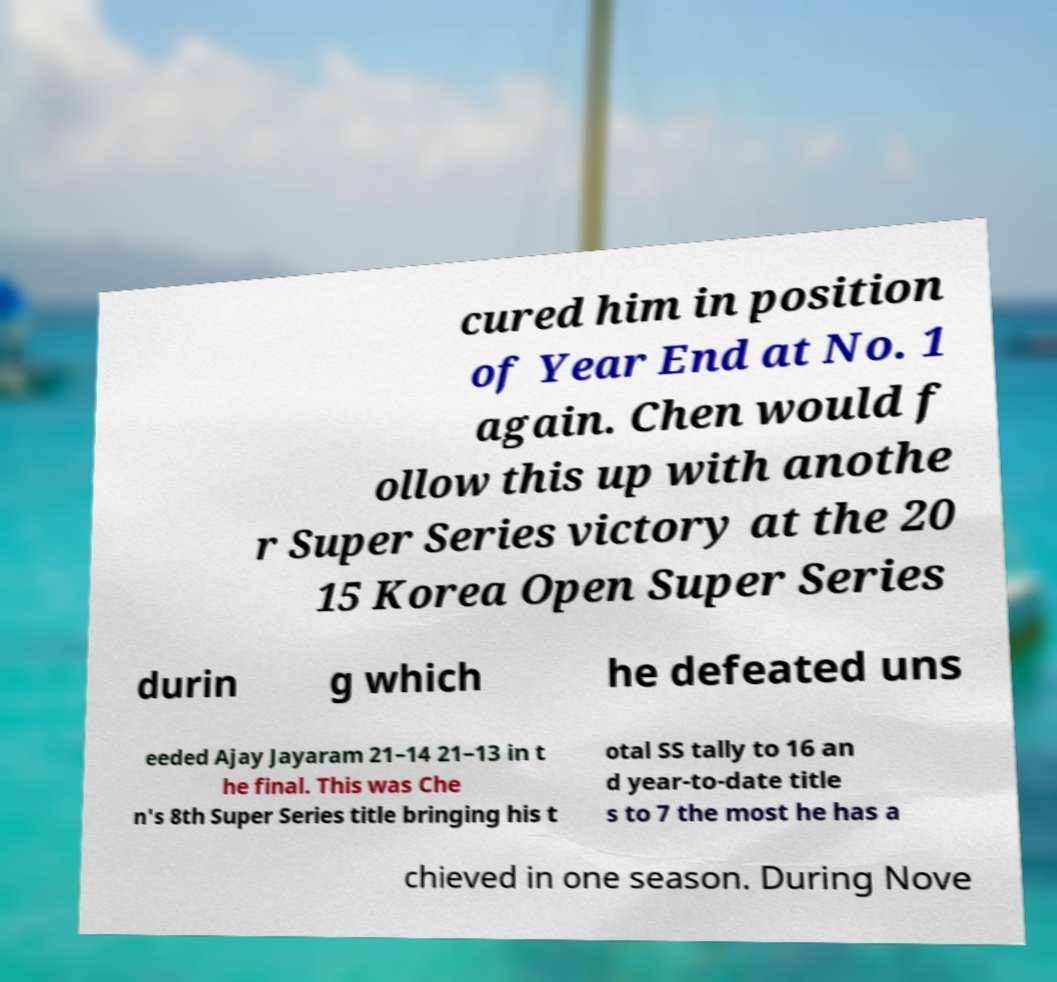For documentation purposes, I need the text within this image transcribed. Could you provide that? cured him in position of Year End at No. 1 again. Chen would f ollow this up with anothe r Super Series victory at the 20 15 Korea Open Super Series durin g which he defeated uns eeded Ajay Jayaram 21–14 21–13 in t he final. This was Che n's 8th Super Series title bringing his t otal SS tally to 16 an d year-to-date title s to 7 the most he has a chieved in one season. During Nove 